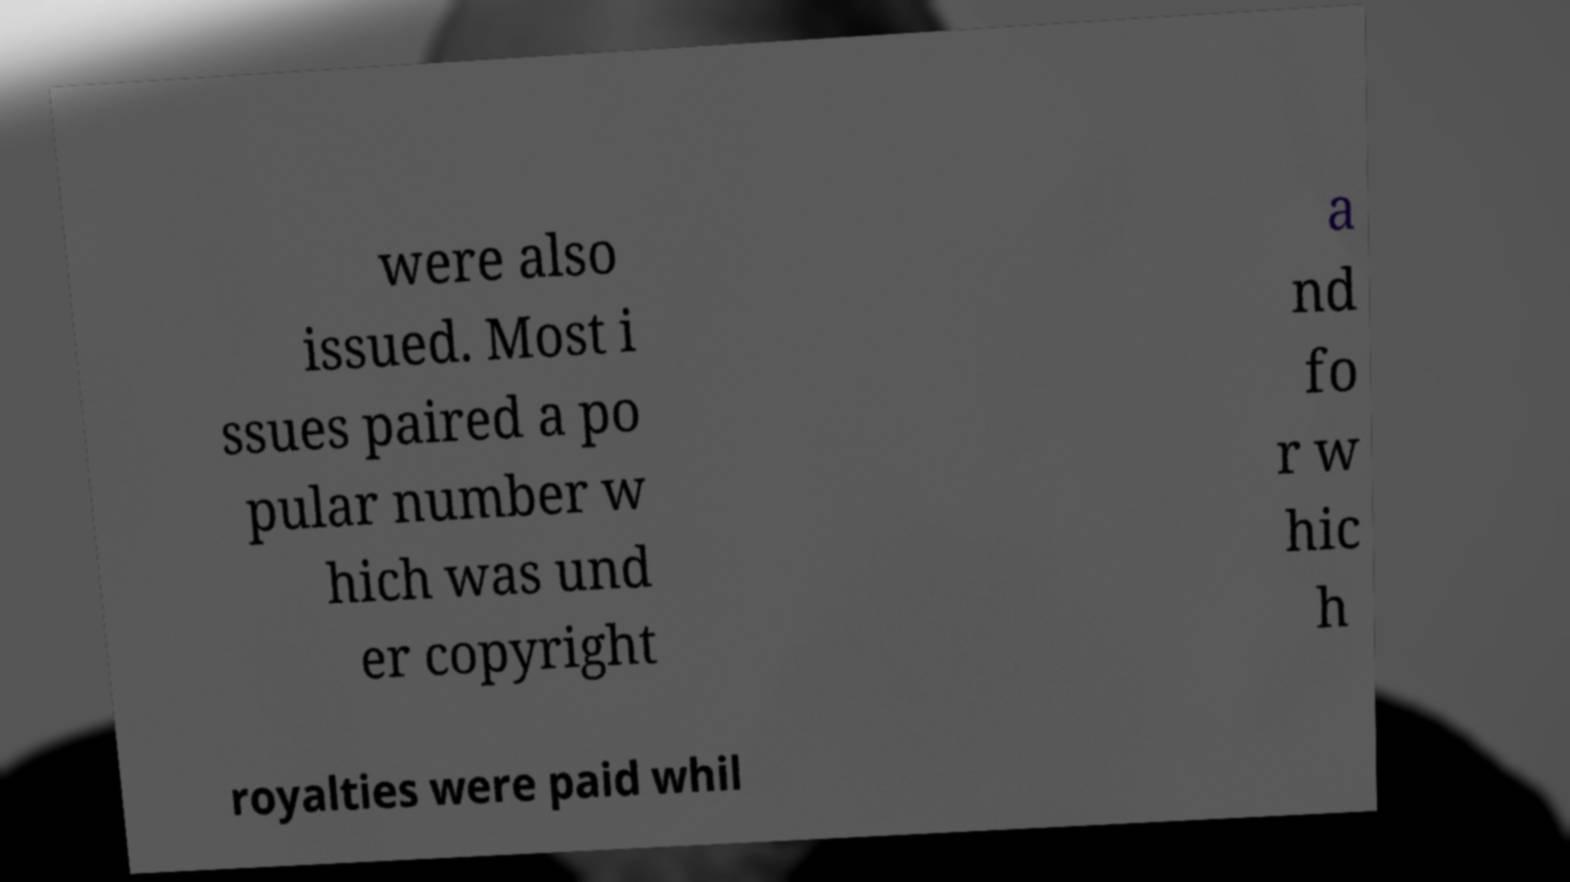For documentation purposes, I need the text within this image transcribed. Could you provide that? were also issued. Most i ssues paired a po pular number w hich was und er copyright a nd fo r w hic h royalties were paid whil 